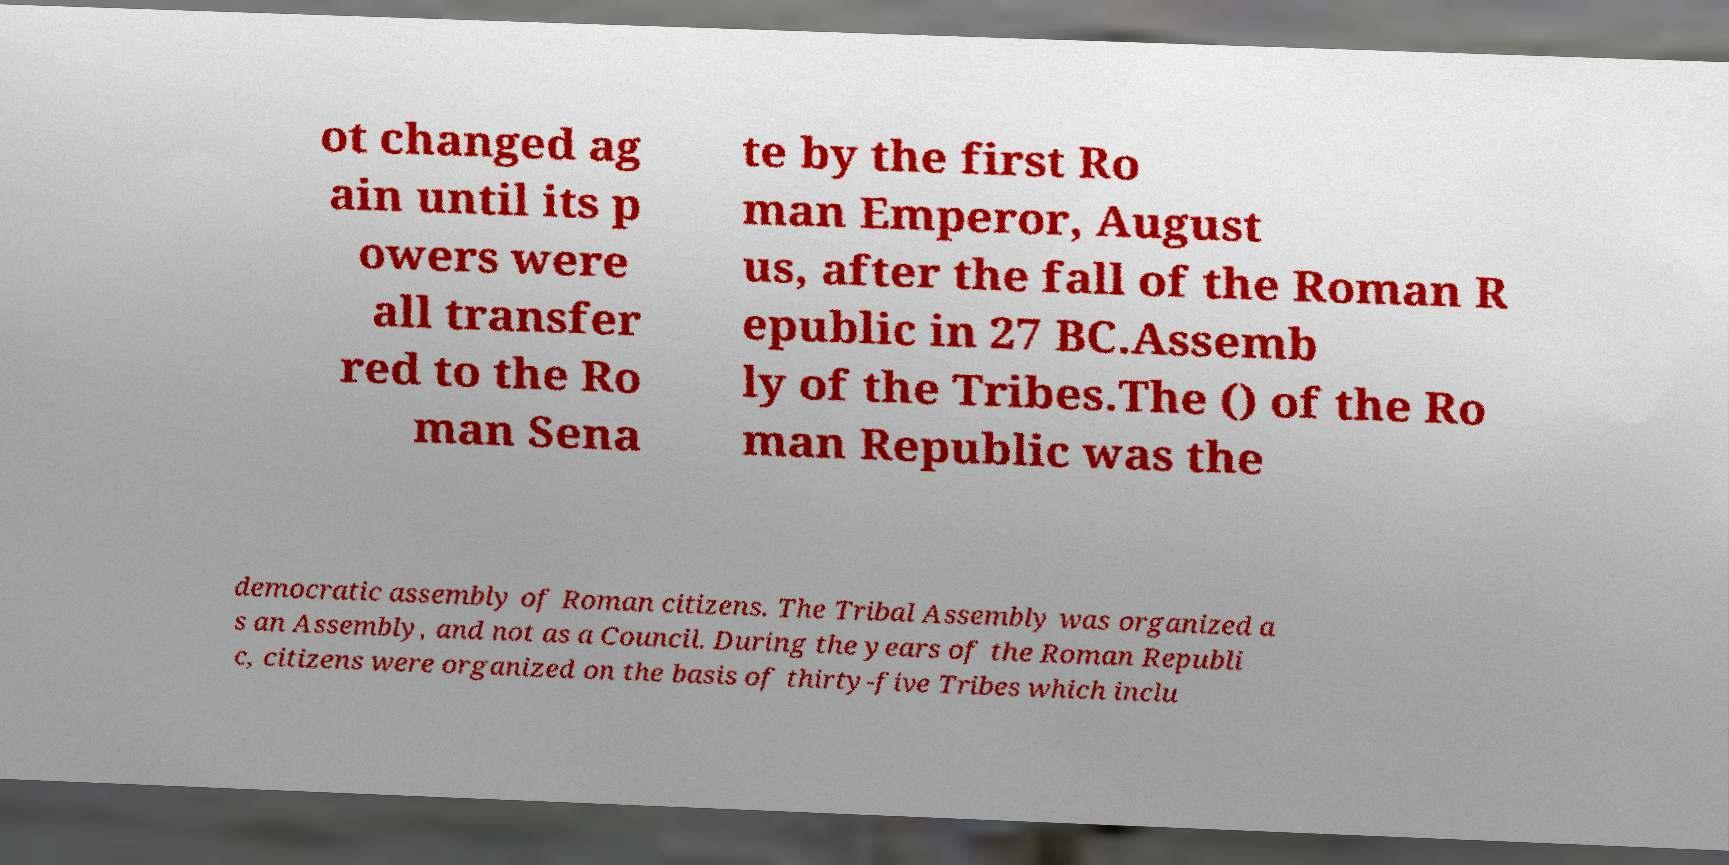What messages or text are displayed in this image? I need them in a readable, typed format. ot changed ag ain until its p owers were all transfer red to the Ro man Sena te by the first Ro man Emperor, August us, after the fall of the Roman R epublic in 27 BC.Assemb ly of the Tribes.The () of the Ro man Republic was the democratic assembly of Roman citizens. The Tribal Assembly was organized a s an Assembly, and not as a Council. During the years of the Roman Republi c, citizens were organized on the basis of thirty-five Tribes which inclu 